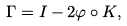Convert formula to latex. <formula><loc_0><loc_0><loc_500><loc_500>\Gamma = I - 2 \varphi \circ K ,</formula> 